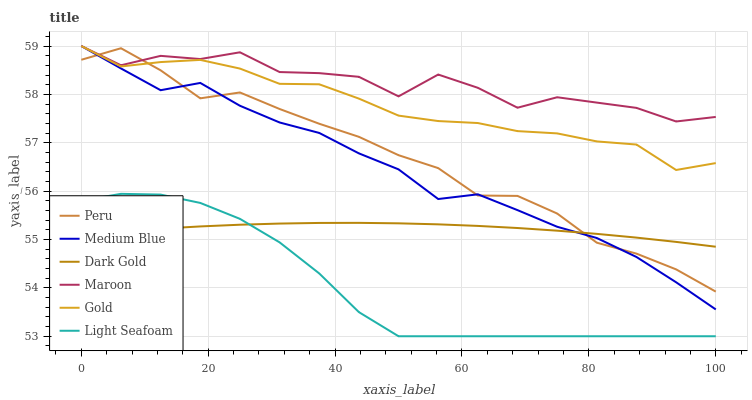Does Light Seafoam have the minimum area under the curve?
Answer yes or no. Yes. Does Maroon have the maximum area under the curve?
Answer yes or no. Yes. Does Dark Gold have the minimum area under the curve?
Answer yes or no. No. Does Dark Gold have the maximum area under the curve?
Answer yes or no. No. Is Dark Gold the smoothest?
Answer yes or no. Yes. Is Maroon the roughest?
Answer yes or no. Yes. Is Medium Blue the smoothest?
Answer yes or no. No. Is Medium Blue the roughest?
Answer yes or no. No. Does Light Seafoam have the lowest value?
Answer yes or no. Yes. Does Dark Gold have the lowest value?
Answer yes or no. No. Does Maroon have the highest value?
Answer yes or no. Yes. Does Dark Gold have the highest value?
Answer yes or no. No. Is Light Seafoam less than Medium Blue?
Answer yes or no. Yes. Is Peru greater than Light Seafoam?
Answer yes or no. Yes. Does Medium Blue intersect Peru?
Answer yes or no. Yes. Is Medium Blue less than Peru?
Answer yes or no. No. Is Medium Blue greater than Peru?
Answer yes or no. No. Does Light Seafoam intersect Medium Blue?
Answer yes or no. No. 